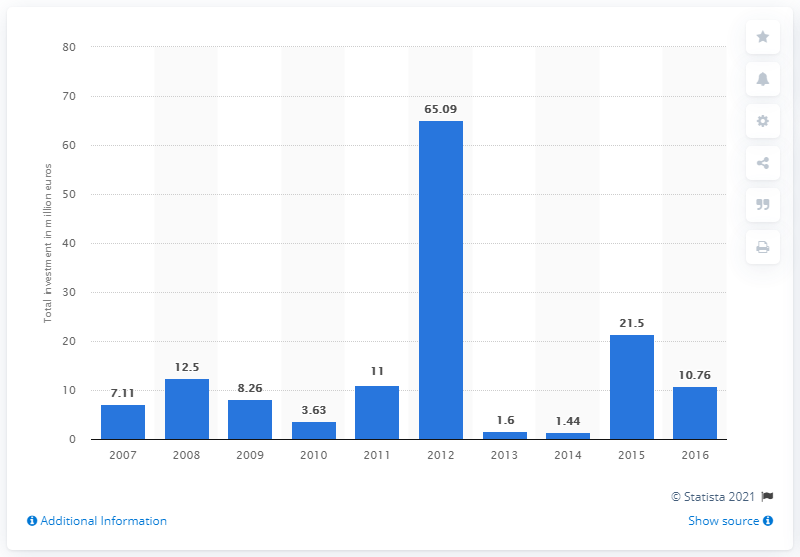Identify some key points in this picture. In 2016, the value of private equity investments in Bulgaria was 10.76. The largest total value of private equity investments was found in 2012. 